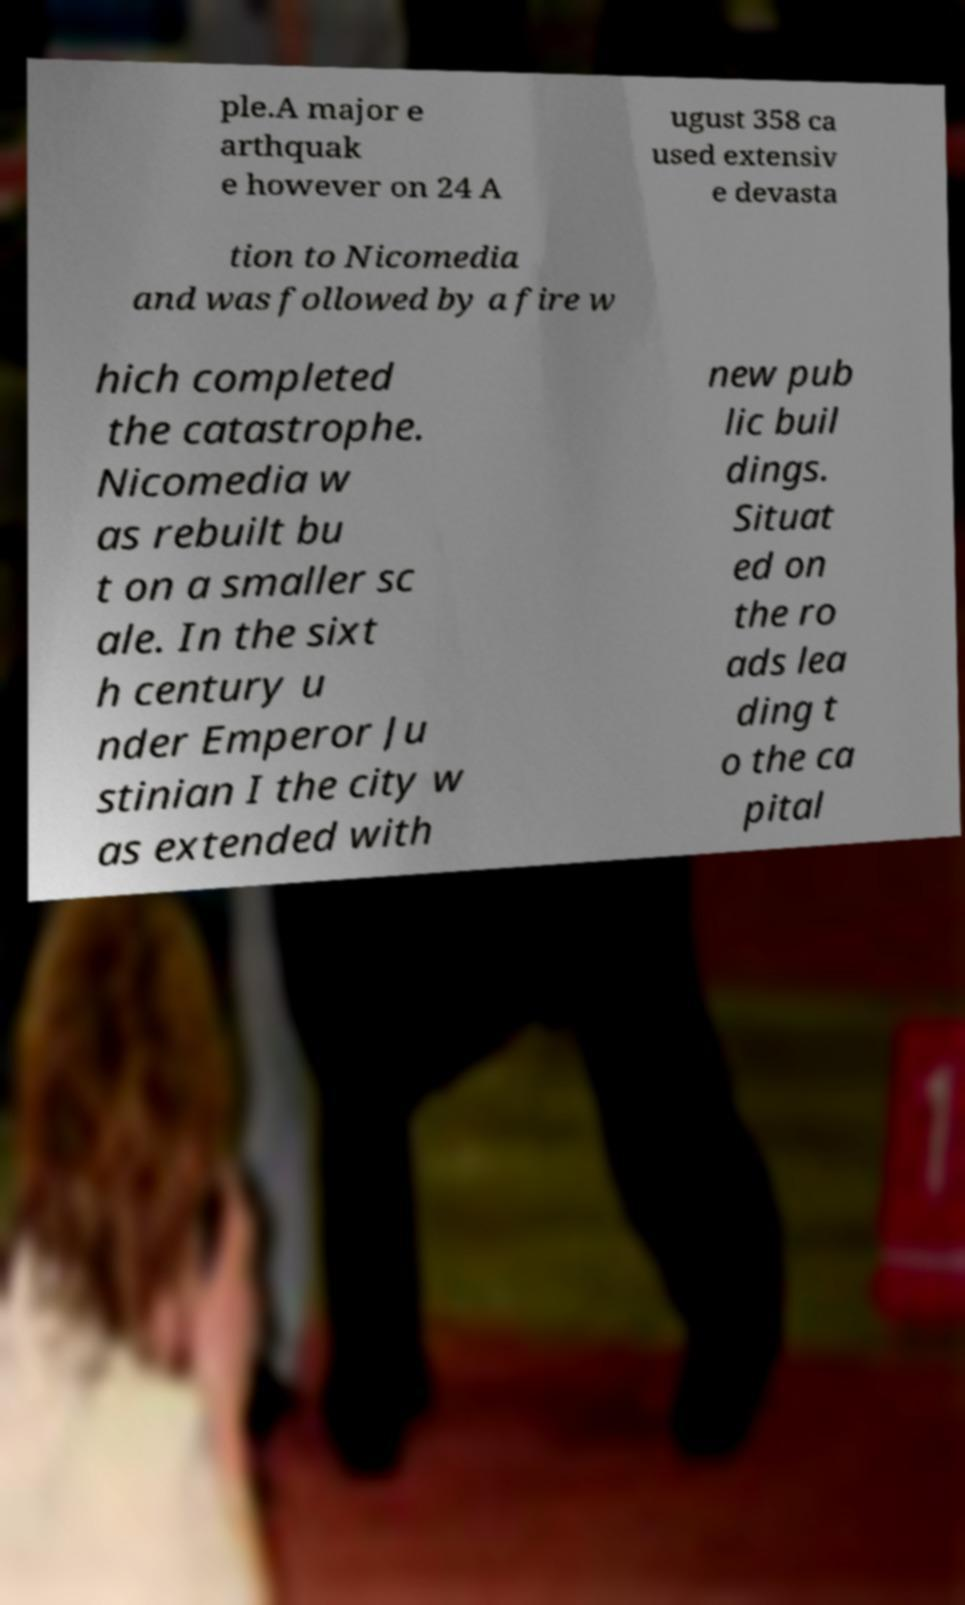What messages or text are displayed in this image? I need them in a readable, typed format. ple.A major e arthquak e however on 24 A ugust 358 ca used extensiv e devasta tion to Nicomedia and was followed by a fire w hich completed the catastrophe. Nicomedia w as rebuilt bu t on a smaller sc ale. In the sixt h century u nder Emperor Ju stinian I the city w as extended with new pub lic buil dings. Situat ed on the ro ads lea ding t o the ca pital 